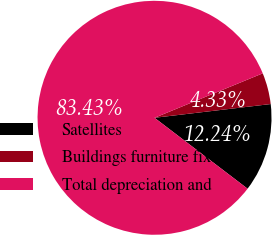Convert chart to OTSL. <chart><loc_0><loc_0><loc_500><loc_500><pie_chart><fcel>Satellites<fcel>Buildings furniture fixtures<fcel>Total depreciation and<nl><fcel>12.24%<fcel>4.33%<fcel>83.44%<nl></chart> 